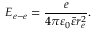Convert formula to latex. <formula><loc_0><loc_0><loc_500><loc_500>E _ { e - e } = \frac { e } { 4 \pi \varepsilon _ { 0 } \bar { \varepsilon } r _ { e } ^ { 2 } } .</formula> 